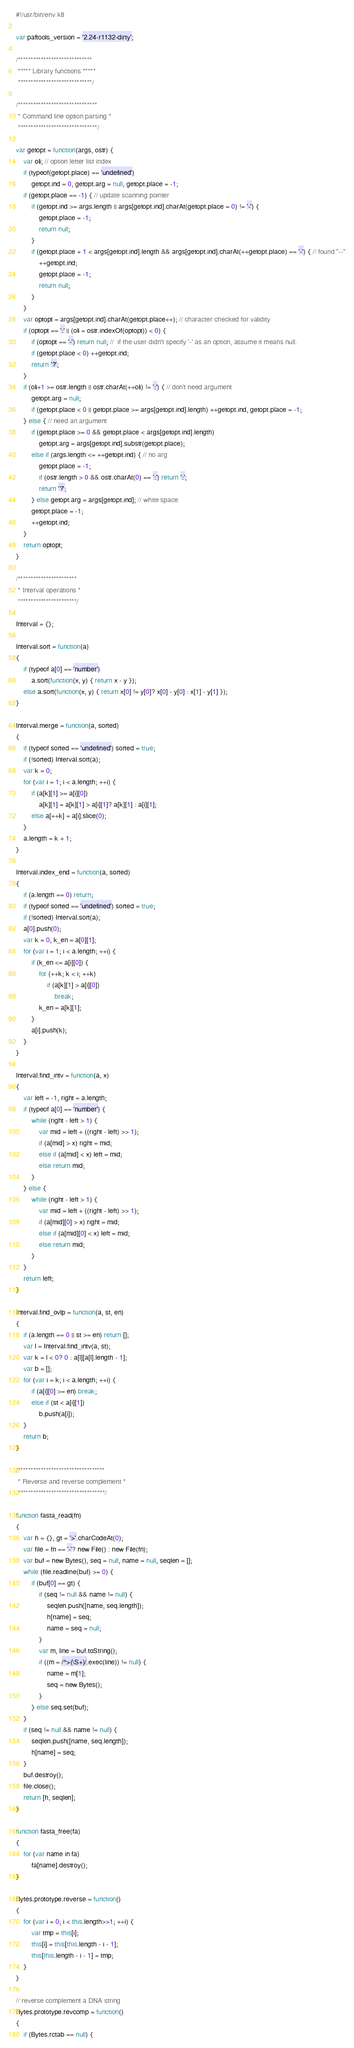<code> <loc_0><loc_0><loc_500><loc_500><_JavaScript_>#!/usr/bin/env k8

var paftools_version = '2.24-r1132-dirty';

/*****************************
 ***** Library functions *****
 *****************************/

/*******************************
 * Command line option parsing *
 *******************************/

var getopt = function(args, ostr) {
	var oli; // option letter list index
	if (typeof(getopt.place) == 'undefined')
		getopt.ind = 0, getopt.arg = null, getopt.place = -1;
	if (getopt.place == -1) { // update scanning pointer
		if (getopt.ind >= args.length || args[getopt.ind].charAt(getopt.place = 0) != '-') {
			getopt.place = -1;
			return null;
		}
		if (getopt.place + 1 < args[getopt.ind].length && args[getopt.ind].charAt(++getopt.place) == '-') { // found "--"
			++getopt.ind;
			getopt.place = -1;
			return null;
		}
	}
	var optopt = args[getopt.ind].charAt(getopt.place++); // character checked for validity
	if (optopt == ':' || (oli = ostr.indexOf(optopt)) < 0) {
		if (optopt == '-') return null; //  if the user didn't specify '-' as an option, assume it means null.
		if (getopt.place < 0) ++getopt.ind;
		return '?';
	}
	if (oli+1 >= ostr.length || ostr.charAt(++oli) != ':') { // don't need argument
		getopt.arg = null;
		if (getopt.place < 0 || getopt.place >= args[getopt.ind].length) ++getopt.ind, getopt.place = -1;
	} else { // need an argument
		if (getopt.place >= 0 && getopt.place < args[getopt.ind].length)
			getopt.arg = args[getopt.ind].substr(getopt.place);
		else if (args.length <= ++getopt.ind) { // no arg
			getopt.place = -1;
			if (ostr.length > 0 && ostr.charAt(0) == ':') return ':';
			return '?';
		} else getopt.arg = args[getopt.ind]; // white space
		getopt.place = -1;
		++getopt.ind;
	}
	return optopt;
}

/***********************
 * Interval operations *
 ***********************/

Interval = {};

Interval.sort = function(a)
{
	if (typeof a[0] == 'number')
		a.sort(function(x, y) { return x - y });
	else a.sort(function(x, y) { return x[0] != y[0]? x[0] - y[0] : x[1] - y[1] });
}

Interval.merge = function(a, sorted)
{
	if (typeof sorted == 'undefined') sorted = true;
	if (!sorted) Interval.sort(a);
	var k = 0;
	for (var i = 1; i < a.length; ++i) {
		if (a[k][1] >= a[i][0])
			a[k][1] = a[k][1] > a[i][1]? a[k][1] : a[i][1];
		else a[++k] = a[i].slice(0);
	}
	a.length = k + 1;
}

Interval.index_end = function(a, sorted)
{
	if (a.length == 0) return;
	if (typeof sorted == 'undefined') sorted = true;
	if (!sorted) Interval.sort(a);
	a[0].push(0);
	var k = 0, k_en = a[0][1];
	for (var i = 1; i < a.length; ++i) {
		if (k_en <= a[i][0]) {
			for (++k; k < i; ++k)
				if (a[k][1] > a[i][0])
					break;
			k_en = a[k][1];
		}
		a[i].push(k);
	}
}

Interval.find_intv = function(a, x)
{
	var left = -1, right = a.length;
	if (typeof a[0] == 'number') {
		while (right - left > 1) {
			var mid = left + ((right - left) >> 1);
			if (a[mid] > x) right = mid;
			else if (a[mid] < x) left = mid;
			else return mid;
		}
	} else {
		while (right - left > 1) {
			var mid = left + ((right - left) >> 1);
			if (a[mid][0] > x) right = mid;
			else if (a[mid][0] < x) left = mid;
			else return mid;
		}
	}
	return left;
}

Interval.find_ovlp = function(a, st, en)
{
	if (a.length == 0 || st >= en) return [];
	var l = Interval.find_intv(a, st);
	var k = l < 0? 0 : a[l][a[l].length - 1];
	var b = [];
	for (var i = k; i < a.length; ++i) {
		if (a[i][0] >= en) break;
		else if (st < a[i][1])
			b.push(a[i]);
	}
	return b;
}

/**********************************
 * Reverse and reverse complement *
 **********************************/

function fasta_read(fn)
{
	var h = {}, gt = '>'.charCodeAt(0);
	var file = fn == '-'? new File() : new File(fn);
	var buf = new Bytes(), seq = null, name = null, seqlen = [];
	while (file.readline(buf) >= 0) {
		if (buf[0] == gt) {
			if (seq != null && name != null) {
				seqlen.push([name, seq.length]);
				h[name] = seq;
				name = seq = null;
			}
			var m, line = buf.toString();
			if ((m = /^>(\S+)/.exec(line)) != null) {
				name = m[1];
				seq = new Bytes();
			}
		} else seq.set(buf);
	}
	if (seq != null && name != null) {
		seqlen.push([name, seq.length]);
		h[name] = seq;
	}
	buf.destroy();
	file.close();
	return [h, seqlen];
}

function fasta_free(fa)
{
	for (var name in fa)
		fa[name].destroy();
}

Bytes.prototype.reverse = function()
{
	for (var i = 0; i < this.length>>1; ++i) {
		var tmp = this[i];
		this[i] = this[this.length - i - 1];
		this[this.length - i - 1] = tmp;
	}
}

// reverse complement a DNA string
Bytes.prototype.revcomp = function()
{
	if (Bytes.rctab == null) {</code> 